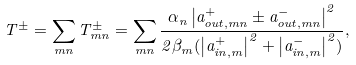Convert formula to latex. <formula><loc_0><loc_0><loc_500><loc_500>T ^ { \pm } = \sum _ { m n } T ^ { \pm } _ { m n } = \sum _ { m n } \frac { \alpha _ { n } \left | a _ { o u t , m n } ^ { + } \pm a _ { o u t , m n } ^ { - } \right | ^ { 2 } } { 2 \beta _ { m } ( \left | a _ { i n , m } ^ { + } \right | ^ { 2 } + \left | a _ { i n , m } ^ { - } \right | ^ { 2 } ) } ,</formula> 